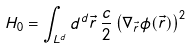<formula> <loc_0><loc_0><loc_500><loc_500>H _ { 0 } = \int _ { L ^ { d } } d ^ { d } \vec { r } \, \frac { c } { 2 } \left ( \nabla _ { \vec { r } } \phi ( \vec { r } ) \right ) ^ { 2 }</formula> 